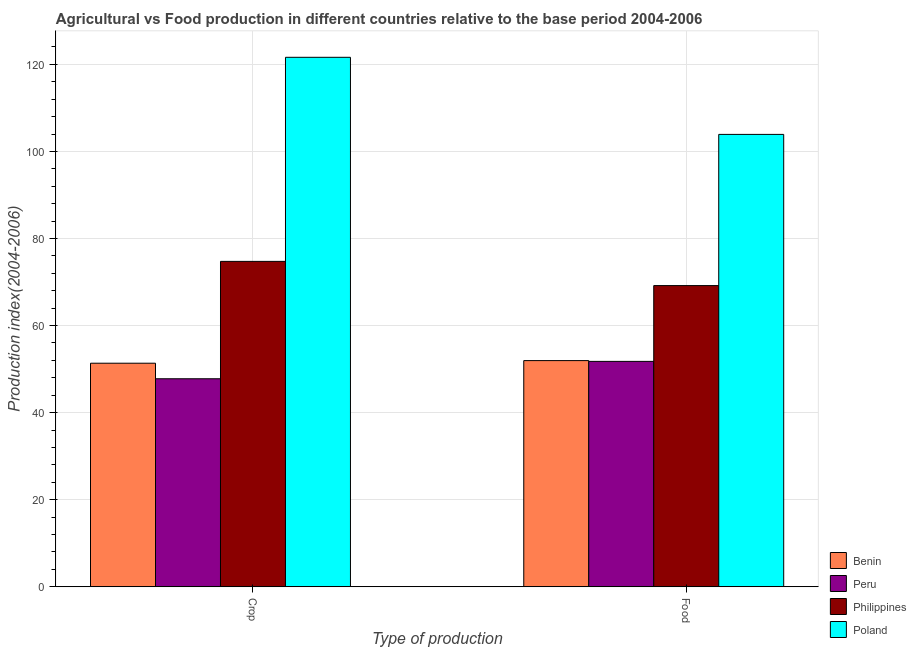How many groups of bars are there?
Your answer should be very brief. 2. Are the number of bars per tick equal to the number of legend labels?
Give a very brief answer. Yes. Are the number of bars on each tick of the X-axis equal?
Your answer should be very brief. Yes. What is the label of the 1st group of bars from the left?
Offer a very short reply. Crop. What is the food production index in Benin?
Your answer should be compact. 51.95. Across all countries, what is the maximum food production index?
Give a very brief answer. 103.91. Across all countries, what is the minimum food production index?
Offer a terse response. 51.77. In which country was the food production index minimum?
Keep it short and to the point. Peru. What is the total crop production index in the graph?
Keep it short and to the point. 295.49. What is the difference between the food production index in Benin and that in Philippines?
Provide a short and direct response. -17.23. What is the difference between the food production index in Peru and the crop production index in Poland?
Ensure brevity in your answer.  -69.85. What is the average food production index per country?
Offer a very short reply. 69.2. What is the difference between the food production index and crop production index in Peru?
Keep it short and to the point. 3.99. In how many countries, is the food production index greater than 60 ?
Offer a terse response. 2. What is the ratio of the crop production index in Poland to that in Peru?
Your answer should be compact. 2.55. In how many countries, is the crop production index greater than the average crop production index taken over all countries?
Your answer should be compact. 2. What does the 1st bar from the left in Crop represents?
Give a very brief answer. Benin. What does the 4th bar from the right in Food represents?
Offer a very short reply. Benin. Are all the bars in the graph horizontal?
Ensure brevity in your answer.  No. What is the difference between two consecutive major ticks on the Y-axis?
Offer a very short reply. 20. Are the values on the major ticks of Y-axis written in scientific E-notation?
Offer a terse response. No. Does the graph contain any zero values?
Offer a terse response. No. How are the legend labels stacked?
Provide a short and direct response. Vertical. What is the title of the graph?
Keep it short and to the point. Agricultural vs Food production in different countries relative to the base period 2004-2006. What is the label or title of the X-axis?
Ensure brevity in your answer.  Type of production. What is the label or title of the Y-axis?
Give a very brief answer. Production index(2004-2006). What is the Production index(2004-2006) of Benin in Crop?
Your answer should be compact. 51.35. What is the Production index(2004-2006) in Peru in Crop?
Provide a succinct answer. 47.78. What is the Production index(2004-2006) of Philippines in Crop?
Your response must be concise. 74.74. What is the Production index(2004-2006) of Poland in Crop?
Ensure brevity in your answer.  121.62. What is the Production index(2004-2006) in Benin in Food?
Provide a short and direct response. 51.95. What is the Production index(2004-2006) of Peru in Food?
Your answer should be very brief. 51.77. What is the Production index(2004-2006) of Philippines in Food?
Ensure brevity in your answer.  69.18. What is the Production index(2004-2006) in Poland in Food?
Provide a succinct answer. 103.91. Across all Type of production, what is the maximum Production index(2004-2006) in Benin?
Your response must be concise. 51.95. Across all Type of production, what is the maximum Production index(2004-2006) in Peru?
Provide a short and direct response. 51.77. Across all Type of production, what is the maximum Production index(2004-2006) of Philippines?
Ensure brevity in your answer.  74.74. Across all Type of production, what is the maximum Production index(2004-2006) in Poland?
Keep it short and to the point. 121.62. Across all Type of production, what is the minimum Production index(2004-2006) in Benin?
Provide a short and direct response. 51.35. Across all Type of production, what is the minimum Production index(2004-2006) of Peru?
Your answer should be very brief. 47.78. Across all Type of production, what is the minimum Production index(2004-2006) in Philippines?
Provide a succinct answer. 69.18. Across all Type of production, what is the minimum Production index(2004-2006) in Poland?
Give a very brief answer. 103.91. What is the total Production index(2004-2006) in Benin in the graph?
Ensure brevity in your answer.  103.3. What is the total Production index(2004-2006) in Peru in the graph?
Make the answer very short. 99.55. What is the total Production index(2004-2006) of Philippines in the graph?
Keep it short and to the point. 143.92. What is the total Production index(2004-2006) of Poland in the graph?
Your response must be concise. 225.53. What is the difference between the Production index(2004-2006) in Peru in Crop and that in Food?
Your response must be concise. -3.99. What is the difference between the Production index(2004-2006) of Philippines in Crop and that in Food?
Ensure brevity in your answer.  5.56. What is the difference between the Production index(2004-2006) of Poland in Crop and that in Food?
Your answer should be very brief. 17.71. What is the difference between the Production index(2004-2006) in Benin in Crop and the Production index(2004-2006) in Peru in Food?
Provide a short and direct response. -0.42. What is the difference between the Production index(2004-2006) of Benin in Crop and the Production index(2004-2006) of Philippines in Food?
Your response must be concise. -17.83. What is the difference between the Production index(2004-2006) of Benin in Crop and the Production index(2004-2006) of Poland in Food?
Offer a very short reply. -52.56. What is the difference between the Production index(2004-2006) in Peru in Crop and the Production index(2004-2006) in Philippines in Food?
Keep it short and to the point. -21.4. What is the difference between the Production index(2004-2006) in Peru in Crop and the Production index(2004-2006) in Poland in Food?
Provide a short and direct response. -56.13. What is the difference between the Production index(2004-2006) of Philippines in Crop and the Production index(2004-2006) of Poland in Food?
Your answer should be very brief. -29.17. What is the average Production index(2004-2006) in Benin per Type of production?
Your answer should be very brief. 51.65. What is the average Production index(2004-2006) in Peru per Type of production?
Keep it short and to the point. 49.77. What is the average Production index(2004-2006) in Philippines per Type of production?
Your answer should be very brief. 71.96. What is the average Production index(2004-2006) of Poland per Type of production?
Your response must be concise. 112.77. What is the difference between the Production index(2004-2006) in Benin and Production index(2004-2006) in Peru in Crop?
Keep it short and to the point. 3.57. What is the difference between the Production index(2004-2006) in Benin and Production index(2004-2006) in Philippines in Crop?
Provide a short and direct response. -23.39. What is the difference between the Production index(2004-2006) in Benin and Production index(2004-2006) in Poland in Crop?
Your answer should be very brief. -70.27. What is the difference between the Production index(2004-2006) of Peru and Production index(2004-2006) of Philippines in Crop?
Your answer should be compact. -26.96. What is the difference between the Production index(2004-2006) in Peru and Production index(2004-2006) in Poland in Crop?
Ensure brevity in your answer.  -73.84. What is the difference between the Production index(2004-2006) in Philippines and Production index(2004-2006) in Poland in Crop?
Offer a very short reply. -46.88. What is the difference between the Production index(2004-2006) in Benin and Production index(2004-2006) in Peru in Food?
Your answer should be very brief. 0.18. What is the difference between the Production index(2004-2006) of Benin and Production index(2004-2006) of Philippines in Food?
Offer a terse response. -17.23. What is the difference between the Production index(2004-2006) of Benin and Production index(2004-2006) of Poland in Food?
Ensure brevity in your answer.  -51.96. What is the difference between the Production index(2004-2006) in Peru and Production index(2004-2006) in Philippines in Food?
Your response must be concise. -17.41. What is the difference between the Production index(2004-2006) of Peru and Production index(2004-2006) of Poland in Food?
Provide a short and direct response. -52.14. What is the difference between the Production index(2004-2006) of Philippines and Production index(2004-2006) of Poland in Food?
Give a very brief answer. -34.73. What is the ratio of the Production index(2004-2006) of Peru in Crop to that in Food?
Your answer should be compact. 0.92. What is the ratio of the Production index(2004-2006) in Philippines in Crop to that in Food?
Your answer should be compact. 1.08. What is the ratio of the Production index(2004-2006) of Poland in Crop to that in Food?
Provide a short and direct response. 1.17. What is the difference between the highest and the second highest Production index(2004-2006) of Benin?
Your answer should be very brief. 0.6. What is the difference between the highest and the second highest Production index(2004-2006) of Peru?
Keep it short and to the point. 3.99. What is the difference between the highest and the second highest Production index(2004-2006) in Philippines?
Keep it short and to the point. 5.56. What is the difference between the highest and the second highest Production index(2004-2006) in Poland?
Make the answer very short. 17.71. What is the difference between the highest and the lowest Production index(2004-2006) of Peru?
Offer a terse response. 3.99. What is the difference between the highest and the lowest Production index(2004-2006) in Philippines?
Your answer should be very brief. 5.56. What is the difference between the highest and the lowest Production index(2004-2006) of Poland?
Your answer should be very brief. 17.71. 